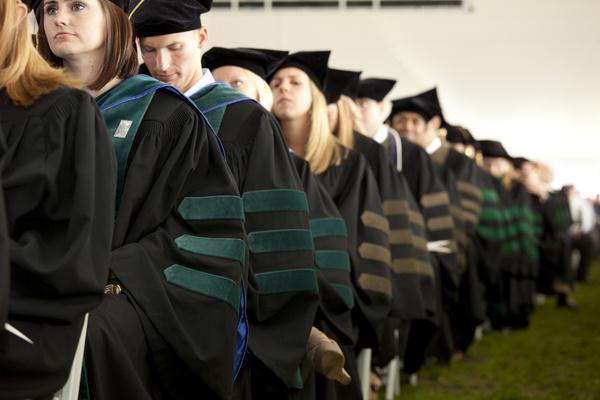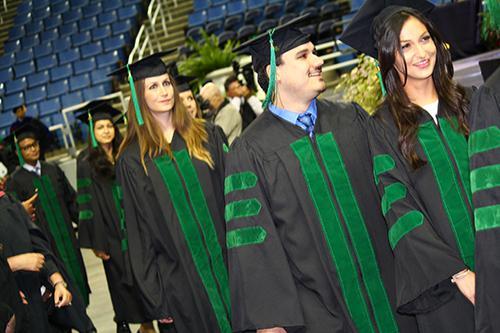The first image is the image on the left, the second image is the image on the right. Assess this claim about the two images: "Blue seats are shown in the auditorium behind the graduates in one of the images.". Correct or not? Answer yes or no. Yes. The first image is the image on the left, the second image is the image on the right. Given the left and right images, does the statement "In one image, graduates are walking forward wearing black robes with green sleeve stripes and caps with green tassles." hold true? Answer yes or no. Yes. 